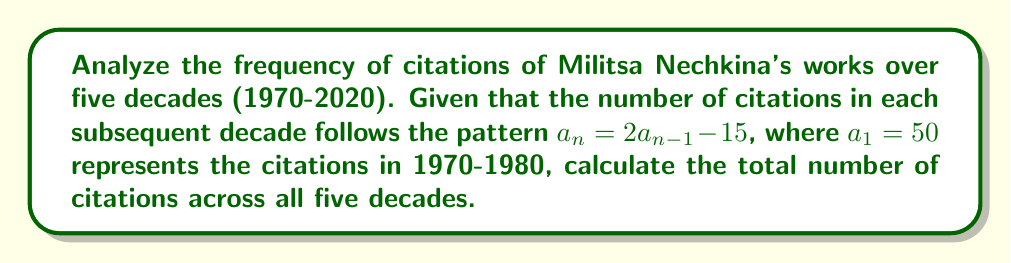Provide a solution to this math problem. Let's approach this step-by-step:

1) We're given that $a_1 = 50$ (citations in 1970-1980) and the sequence follows $a_n = 2a_{n-1} - 15$.

2) Let's calculate the citations for each decade:

   For 1980-1990 (n=2): 
   $a_2 = 2a_1 - 15 = 2(50) - 15 = 85$

   For 1990-2000 (n=3):
   $a_3 = 2a_2 - 15 = 2(85) - 15 = 155$

   For 2000-2010 (n=4):
   $a_4 = 2a_3 - 15 = 2(155) - 15 = 295$

   For 2010-2020 (n=5):
   $a_5 = 2a_4 - 15 = 2(295) - 15 = 575$

3) Now, we need to sum all these values:

   $S = a_1 + a_2 + a_3 + a_4 + a_5$
   $S = 50 + 85 + 155 + 295 + 575 = 1160$

Therefore, the total number of citations across all five decades is 1160.
Answer: 1160 